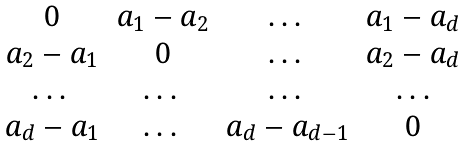<formula> <loc_0><loc_0><loc_500><loc_500>\begin{matrix} 0 & a _ { 1 } - a _ { 2 } & \dots & a _ { 1 } - a _ { d } \\ a _ { 2 } - a _ { 1 } & 0 & \dots & a _ { 2 } - a _ { d } \\ \dots & \dots & \dots & \dots \\ a _ { d } - a _ { 1 } & \dots & a _ { d } - a _ { d - 1 } & 0 \end{matrix}</formula> 